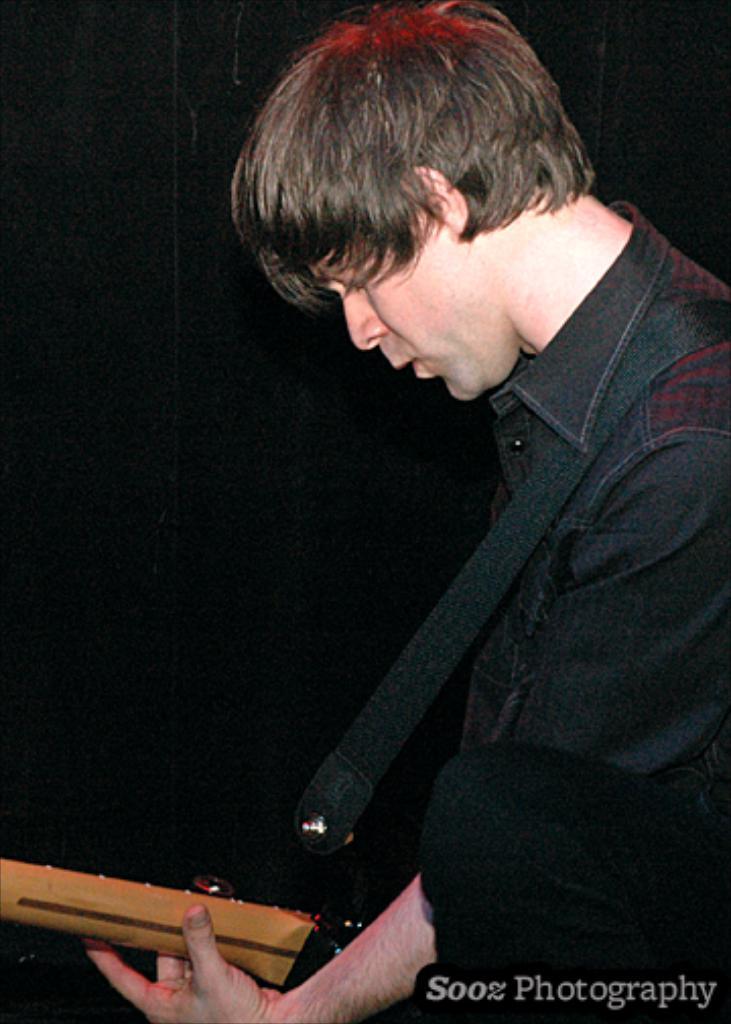In one or two sentences, can you explain what this image depicts? In this image in the front there is a person standing and holding a musical instrument in his hand. 